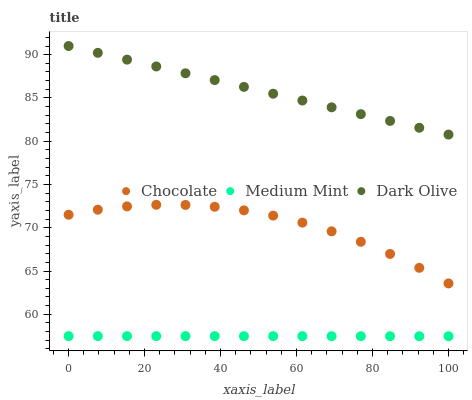Does Medium Mint have the minimum area under the curve?
Answer yes or no. Yes. Does Dark Olive have the maximum area under the curve?
Answer yes or no. Yes. Does Chocolate have the minimum area under the curve?
Answer yes or no. No. Does Chocolate have the maximum area under the curve?
Answer yes or no. No. Is Dark Olive the smoothest?
Answer yes or no. Yes. Is Chocolate the roughest?
Answer yes or no. Yes. Is Chocolate the smoothest?
Answer yes or no. No. Is Dark Olive the roughest?
Answer yes or no. No. Does Medium Mint have the lowest value?
Answer yes or no. Yes. Does Chocolate have the lowest value?
Answer yes or no. No. Does Dark Olive have the highest value?
Answer yes or no. Yes. Does Chocolate have the highest value?
Answer yes or no. No. Is Chocolate less than Dark Olive?
Answer yes or no. Yes. Is Dark Olive greater than Medium Mint?
Answer yes or no. Yes. Does Chocolate intersect Dark Olive?
Answer yes or no. No. 